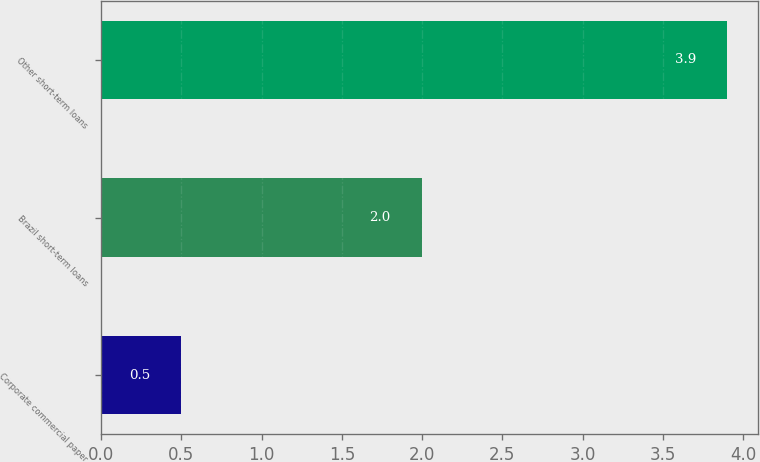Convert chart to OTSL. <chart><loc_0><loc_0><loc_500><loc_500><bar_chart><fcel>Corporate commercial paper<fcel>Brazil short-term loans<fcel>Other short-term loans<nl><fcel>0.5<fcel>2<fcel>3.9<nl></chart> 